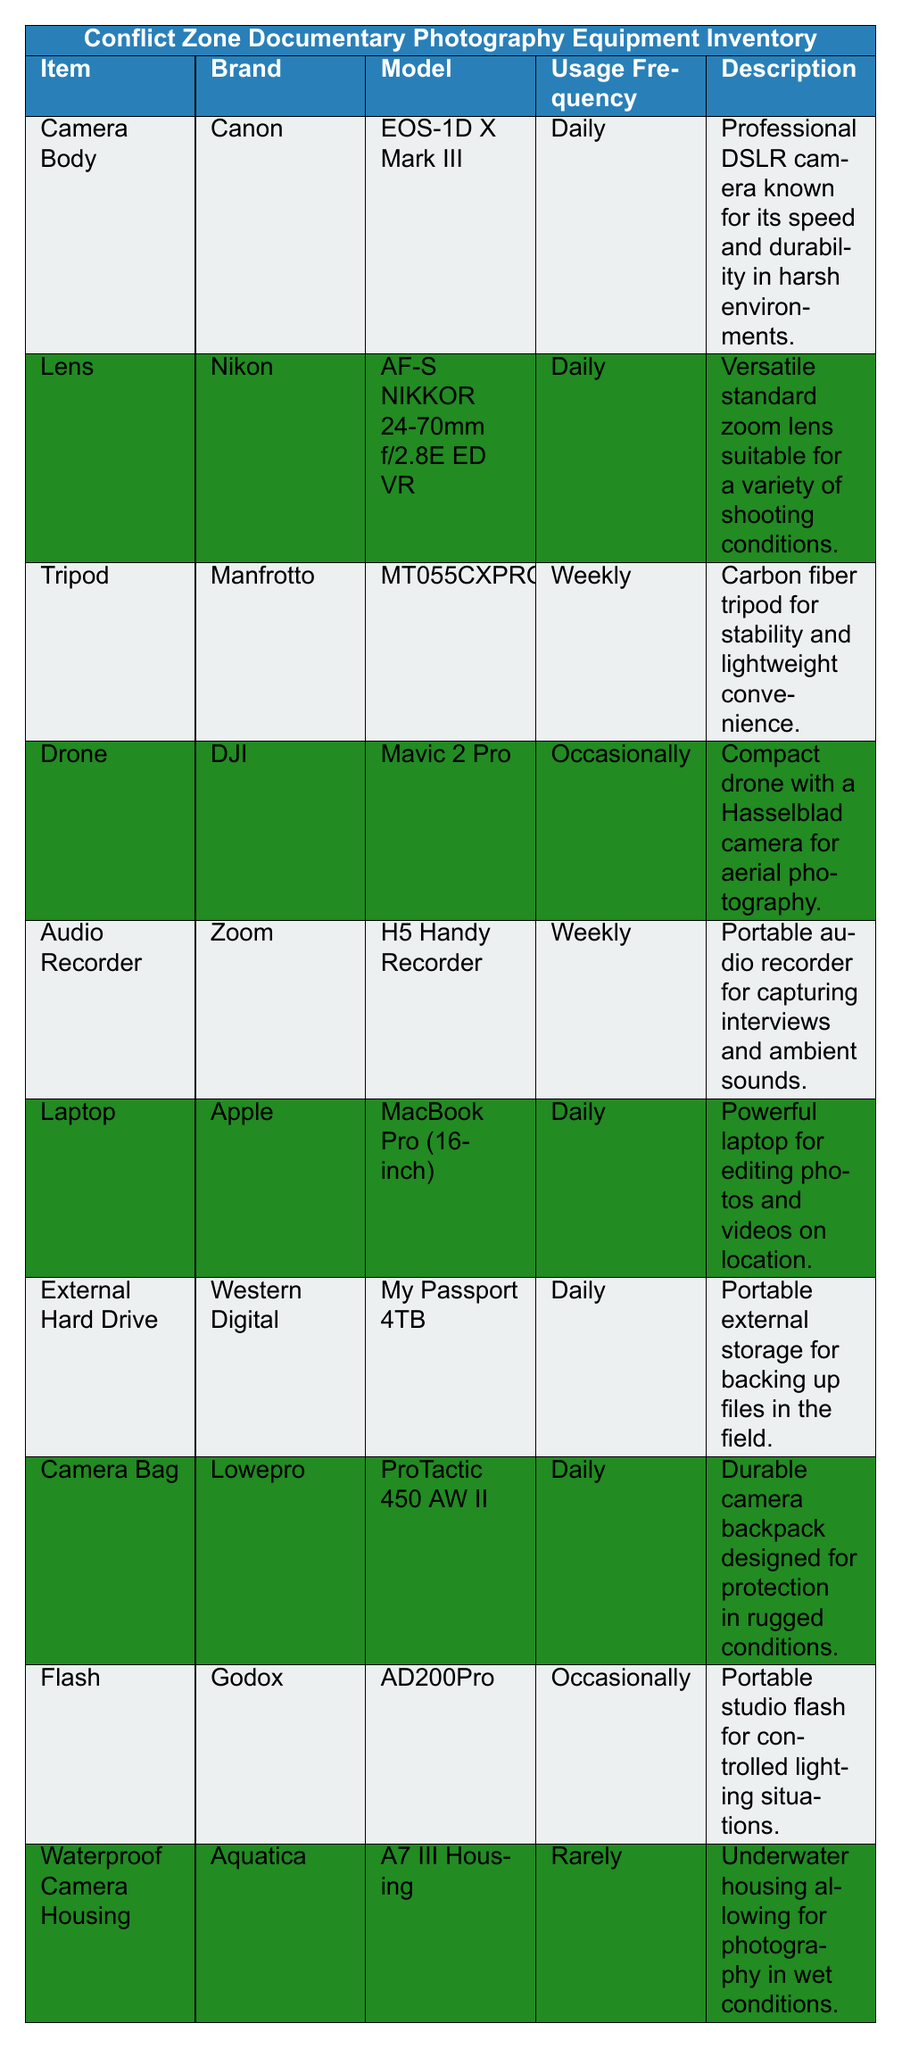What is the brand of the Camera Body? The table lists the Camera Body under the "Item" column with the corresponding "Brand" listed next to it. The brand for the Camera Body is Canon.
Answer: Canon How frequently is the Drone used? The usage frequency for the Drone is directly provided in the "Usage Frequency" column. It states that the Drone is used Occasionally.
Answer: Occasionally Which item has the lowest usage frequency? To determine the lowest usage frequency, we can compare the values in the "Usage Frequency" column. The item with the lowest frequency, 'Rarely', is the Waterproof Camera Housing.
Answer: Waterproof Camera Housing How many items are listed as used daily? We can count the items listed under the "Usage Frequency" column that specify "Daily." There are five items listed as used Daily: Camera Body, Lens, Laptop, External Hard Drive, and Camera Bag.
Answer: 5 Is the Audio Recorder used more frequently than the Tripod? We compare the "Usage Frequency" of both items; the Audio Recorder is used Weekly, while the Tripod is also used Weekly. Since they are the same, the Audio Recorder is not used more frequently than the Tripod.
Answer: No Which brand has more items listed in the inventory? First, we need to tally the brands from the "Brand" column. Canon (1), Nikon (1), Manfrotto (1), DJI (1), Zoom (1), Apple (1), Western Digital (1), Lowepro (1), Godox (1), Aquatica (1) show that all brands have only one item listed. Thus, no brand has more than another.
Answer: None What types of equipment are categorized as "Weekly" use? We can check the "Usage Frequency" column for items marked as "Weekly." The items are Tripod and Audio Recorder.
Answer: Tripod, Audio Recorder Which item is described as suitable for underwater photography? The description provided in the table mentions that the Waterproof Camera Housing is specifically designed for underwater photography.
Answer: Waterproof Camera Housing What percentage of items are used daily? To find the percentage, we first identify that there are 10 items total, and 5 of them are classified as "Daily." Therefore, the percentage is (5/10) * 100 = 50%.
Answer: 50% Does the Drone have a higher usage frequency than the Flash? We check the "Usage Frequency" for both items; the Drone is labeled as Occasionally, and the Flash also has an usage frequency of Occasionally. Therefore, they have the same frequency.
Answer: No If I needed to backup files on location, which item would I use? Referring to the descriptions in the table, the item relevant for backing up files is the External Hard Drive, which is noted for such purposes.
Answer: External Hard Drive 